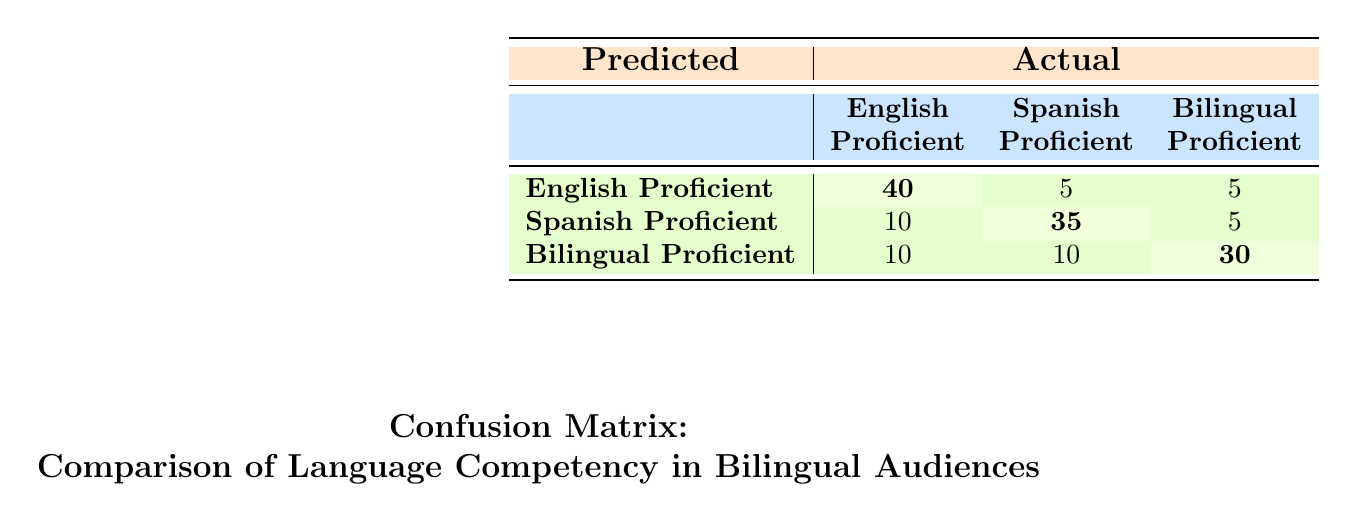What is the number of English Proficient individuals predicted to be English Proficient? The table shows that the predicted number of individuals who are English Proficient and actually classified as English Proficient is 40, as indicated in the first row and first column of the table.
Answer: 40 What is the total number of Spanish Proficient individuals predicted across all categories? To find the total number of Spanish Proficient individuals across all predicted categories, we sum the values in the Spanish Proficient column: 5 (from English Proficient) + 35 (from Spanish Proficient) + 10 (from Bilingual Proficient) = 50.
Answer: 50 Is it true that more individuals are predicted to be bilingual competent than Spanish competent? We look at the predicted number of individuals classified as Bilingual Proficient (30) compared to those classified as Spanish Proficient (35). Since 30 is less than 35, the statement is false.
Answer: False What is the prediction for the number of Bilingual Proficient individuals who are actually classified as Spanish Proficient? The table indicates that the predicted number of Bilingual Proficient individuals classified as Spanish Proficient is 10, found in the third row and second column.
Answer: 10 What is the percentage of English Proficient individuals who were correctly predicted as English Proficient? To calculate the percentage, divide the number of correctly predicted English Proficient individuals (40) by the total number of individuals predicted as English Proficient (40 + 5 + 5 = 50). Thus, the percentage is (40/50) * 100 = 80%.
Answer: 80% How many more individuals are predicted to be Spanish Proficient than Bilingual Proficient? The predicted number of Spanish Proficient individuals is 35, and the predicted number of Bilingual Proficient individuals is 30. Subtracting the two gives us 35 - 30 = 5, indicating that 5 more individuals are predicted to be Spanish Proficient.
Answer: 5 What is the total number of individuals predicted to be English Proficient? The total number of individuals predicted as English Proficient is the sum of all entries in the first row: 40 (correctly predicted) + 5 (predicted as Spanish) + 5 (predicted as Bilingual) = 50.
Answer: 50 How many individuals were incorrectly predicted as Bilingual Proficient? The total number of individuals predicted as Bilingual Proficient is 10 (predicted as English) + 10 (predicted as Spanish) = 20. Since the correct prediction for Bilingual Proficient is 30, the total incorrectly predicted is 20 - 30 = -10, indicating that there is no incorrect prediction here, so the question confirms the individuals actually predicted as Bilingual Proficient.
Answer: 20 